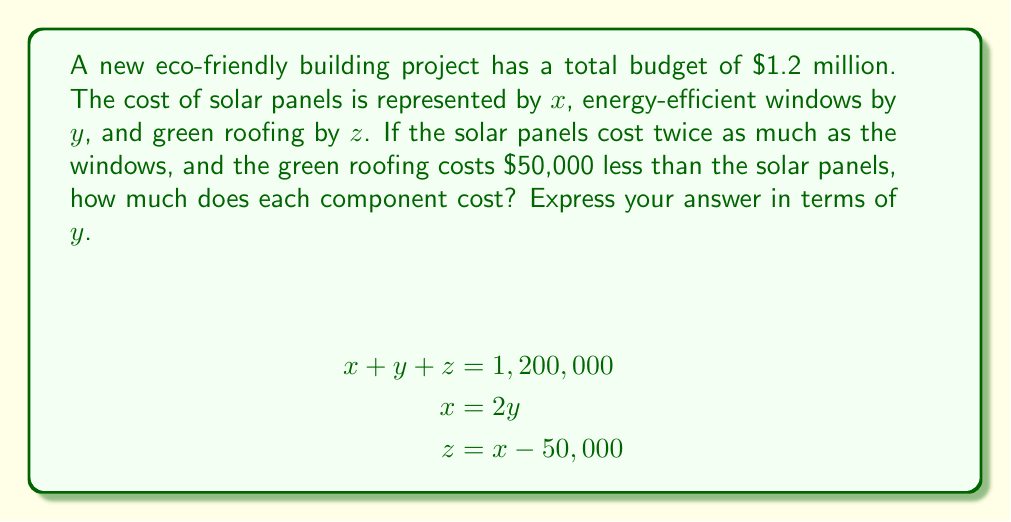Teach me how to tackle this problem. Let's solve this step-by-step:

1) We're given three equations:
   $$x + y + z = 1,200,000$$ (total budget)
   $$x = 2y$$ (solar panels cost twice as windows)
   $$z = x - 50,000$$ (green roofing costs $50,000 less than solar panels)

2) Let's substitute $x = 2y$ into the third equation:
   $$z = 2y - 50,000$$

3) Now, let's substitute both $x = 2y$ and $z = 2y - 50,000$ into the first equation:
   $$2y + y + (2y - 50,000) = 1,200,000$$

4) Simplify:
   $$5y - 50,000 = 1,200,000$$

5) Add 50,000 to both sides:
   $$5y = 1,250,000$$

6) Divide both sides by 5:
   $$y = 250,000$$

7) Now we can find $x$ and $z$:
   $x = 2y = 2(250,000) = 500,000$
   $z = x - 50,000 = 500,000 - 50,000 = 450,000$

8) Express all values in terms of $y$:
   $x = 2y$
   $y = y$
   $z = 2y - 50,000$
Answer: $x = 2y$, $y = y$, $z = 2y - 50,000$ 